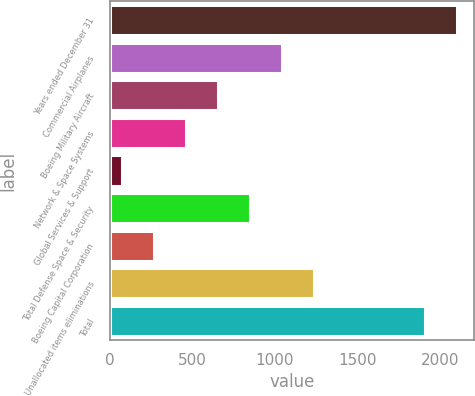<chart> <loc_0><loc_0><loc_500><loc_500><bar_chart><fcel>Years ended December 31<fcel>Commercial Airplanes<fcel>Boeing Military Aircraft<fcel>Network & Space Systems<fcel>Global Services & Support<fcel>Total Defense Space & Security<fcel>Boeing Capital Corporation<fcel>Unallocated items eliminations<fcel>Total<nl><fcel>2099.9<fcel>1044.5<fcel>656.7<fcel>462.8<fcel>75<fcel>850.6<fcel>268.9<fcel>1238.4<fcel>1906<nl></chart> 